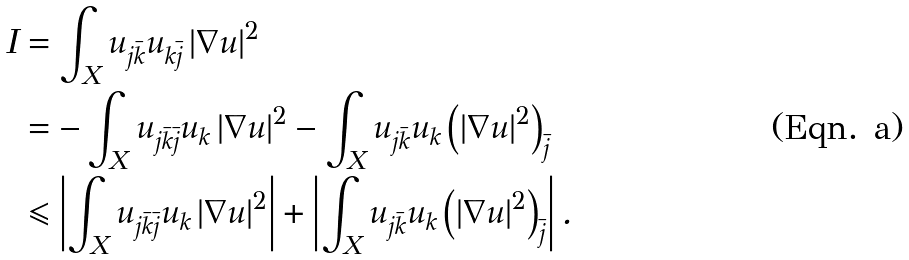Convert formula to latex. <formula><loc_0><loc_0><loc_500><loc_500>I & = \int _ { X } u _ { j \bar { k } } u _ { k \bar { j } } \left | \nabla u \right | ^ { 2 } \\ & = - \int _ { X } u _ { j \bar { k } \bar { j } } u _ { k } \left | \nabla u \right | ^ { 2 } - \int _ { X } u _ { j \bar { k } } u _ { k } \left ( \left | \nabla u \right | ^ { 2 } \right ) _ { \bar { j } } \\ & \leqslant \left | \int _ { X } u _ { j \bar { k } \bar { j } } u _ { k } \left | \nabla u \right | ^ { 2 } \right | + \left | \int _ { X } u _ { j \bar { k } } u _ { k } \left ( \left | \nabla u \right | ^ { 2 } \right ) _ { \bar { j } } \right | .</formula> 